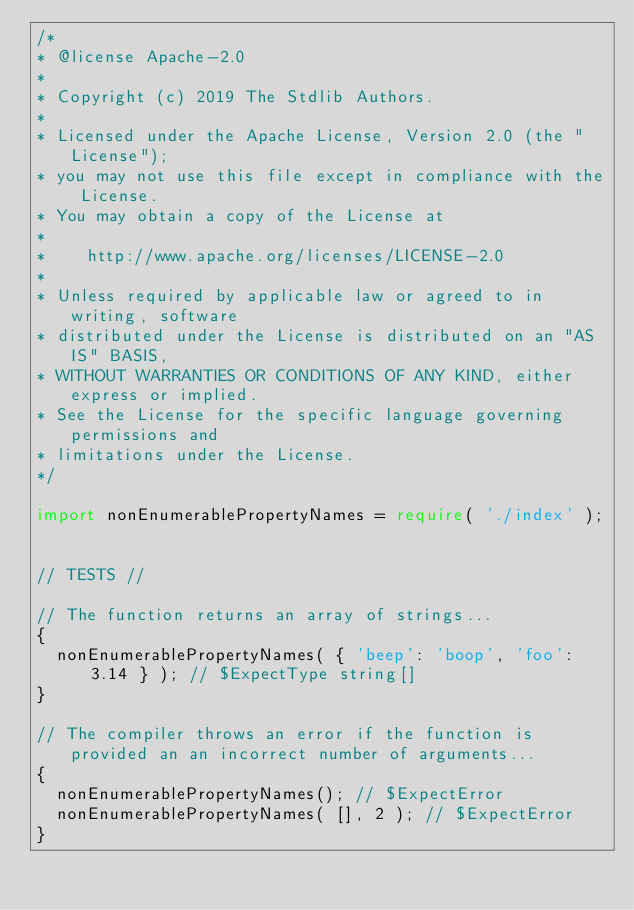<code> <loc_0><loc_0><loc_500><loc_500><_TypeScript_>/*
* @license Apache-2.0
*
* Copyright (c) 2019 The Stdlib Authors.
*
* Licensed under the Apache License, Version 2.0 (the "License");
* you may not use this file except in compliance with the License.
* You may obtain a copy of the License at
*
*    http://www.apache.org/licenses/LICENSE-2.0
*
* Unless required by applicable law or agreed to in writing, software
* distributed under the License is distributed on an "AS IS" BASIS,
* WITHOUT WARRANTIES OR CONDITIONS OF ANY KIND, either express or implied.
* See the License for the specific language governing permissions and
* limitations under the License.
*/

import nonEnumerablePropertyNames = require( './index' );


// TESTS //

// The function returns an array of strings...
{
	nonEnumerablePropertyNames( { 'beep': 'boop', 'foo': 3.14 } ); // $ExpectType string[]
}

// The compiler throws an error if the function is provided an an incorrect number of arguments...
{
	nonEnumerablePropertyNames(); // $ExpectError
	nonEnumerablePropertyNames( [], 2 ); // $ExpectError
}
</code> 